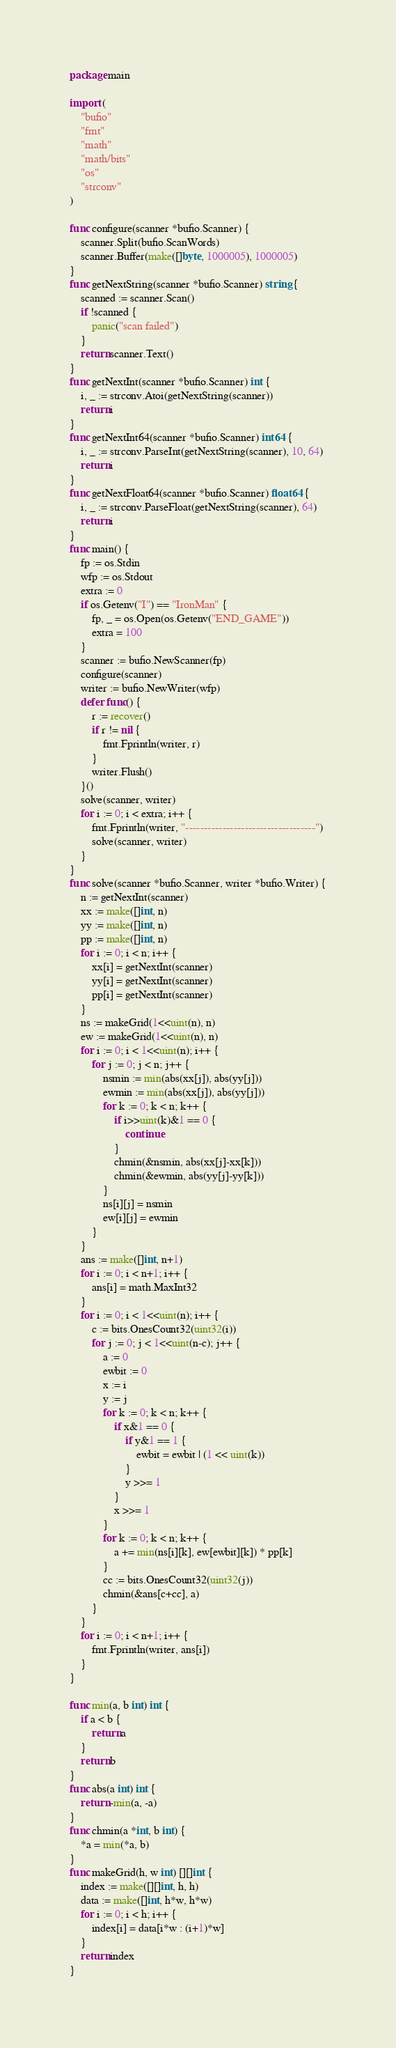<code> <loc_0><loc_0><loc_500><loc_500><_Go_>package main

import (
	"bufio"
	"fmt"
	"math"
	"math/bits"
	"os"
	"strconv"
)

func configure(scanner *bufio.Scanner) {
	scanner.Split(bufio.ScanWords)
	scanner.Buffer(make([]byte, 1000005), 1000005)
}
func getNextString(scanner *bufio.Scanner) string {
	scanned := scanner.Scan()
	if !scanned {
		panic("scan failed")
	}
	return scanner.Text()
}
func getNextInt(scanner *bufio.Scanner) int {
	i, _ := strconv.Atoi(getNextString(scanner))
	return i
}
func getNextInt64(scanner *bufio.Scanner) int64 {
	i, _ := strconv.ParseInt(getNextString(scanner), 10, 64)
	return i
}
func getNextFloat64(scanner *bufio.Scanner) float64 {
	i, _ := strconv.ParseFloat(getNextString(scanner), 64)
	return i
}
func main() {
	fp := os.Stdin
	wfp := os.Stdout
	extra := 0
	if os.Getenv("I") == "IronMan" {
		fp, _ = os.Open(os.Getenv("END_GAME"))
		extra = 100
	}
	scanner := bufio.NewScanner(fp)
	configure(scanner)
	writer := bufio.NewWriter(wfp)
	defer func() {
		r := recover()
		if r != nil {
			fmt.Fprintln(writer, r)
		}
		writer.Flush()
	}()
	solve(scanner, writer)
	for i := 0; i < extra; i++ {
		fmt.Fprintln(writer, "-----------------------------------")
		solve(scanner, writer)
	}
}
func solve(scanner *bufio.Scanner, writer *bufio.Writer) {
	n := getNextInt(scanner)
	xx := make([]int, n)
	yy := make([]int, n)
	pp := make([]int, n)
	for i := 0; i < n; i++ {
		xx[i] = getNextInt(scanner)
		yy[i] = getNextInt(scanner)
		pp[i] = getNextInt(scanner)
	}
	ns := makeGrid(1<<uint(n), n)
	ew := makeGrid(1<<uint(n), n)
	for i := 0; i < 1<<uint(n); i++ {
		for j := 0; j < n; j++ {
			nsmin := min(abs(xx[j]), abs(yy[j]))
			ewmin := min(abs(xx[j]), abs(yy[j]))
			for k := 0; k < n; k++ {
				if i>>uint(k)&1 == 0 {
					continue
				}
				chmin(&nsmin, abs(xx[j]-xx[k]))
				chmin(&ewmin, abs(yy[j]-yy[k]))
			}
			ns[i][j] = nsmin
			ew[i][j] = ewmin
		}
	}
	ans := make([]int, n+1)
	for i := 0; i < n+1; i++ {
		ans[i] = math.MaxInt32
	}
	for i := 0; i < 1<<uint(n); i++ {
		c := bits.OnesCount32(uint32(i))
		for j := 0; j < 1<<uint(n-c); j++ {
			a := 0
			ewbit := 0
			x := i
			y := j
			for k := 0; k < n; k++ {
				if x&1 == 0 {
					if y&1 == 1 {
						ewbit = ewbit | (1 << uint(k))
					}
					y >>= 1
				}
				x >>= 1
			}
			for k := 0; k < n; k++ {
				a += min(ns[i][k], ew[ewbit][k]) * pp[k]
			}
			cc := bits.OnesCount32(uint32(j))
			chmin(&ans[c+cc], a)
		}
	}
	for i := 0; i < n+1; i++ {
		fmt.Fprintln(writer, ans[i])
	}
}

func min(a, b int) int {
	if a < b {
		return a
	}
	return b
}
func abs(a int) int {
	return -min(a, -a)
}
func chmin(a *int, b int) {
	*a = min(*a, b)
}
func makeGrid(h, w int) [][]int {
	index := make([][]int, h, h)
	data := make([]int, h*w, h*w)
	for i := 0; i < h; i++ {
		index[i] = data[i*w : (i+1)*w]
	}
	return index
}
</code> 